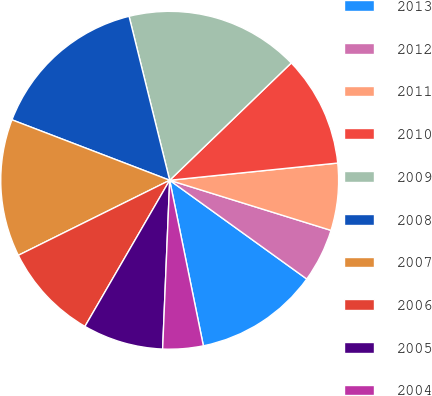<chart> <loc_0><loc_0><loc_500><loc_500><pie_chart><fcel>2013<fcel>2012<fcel>2011<fcel>2010<fcel>2009<fcel>2008<fcel>2007<fcel>2006<fcel>2005<fcel>2004<nl><fcel>11.87%<fcel>5.14%<fcel>6.42%<fcel>10.59%<fcel>16.65%<fcel>15.31%<fcel>13.15%<fcel>9.31%<fcel>7.7%<fcel>3.86%<nl></chart> 